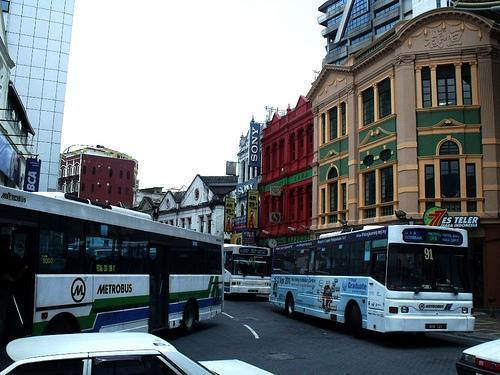How many buses are shown?
Give a very brief answer. 3. 